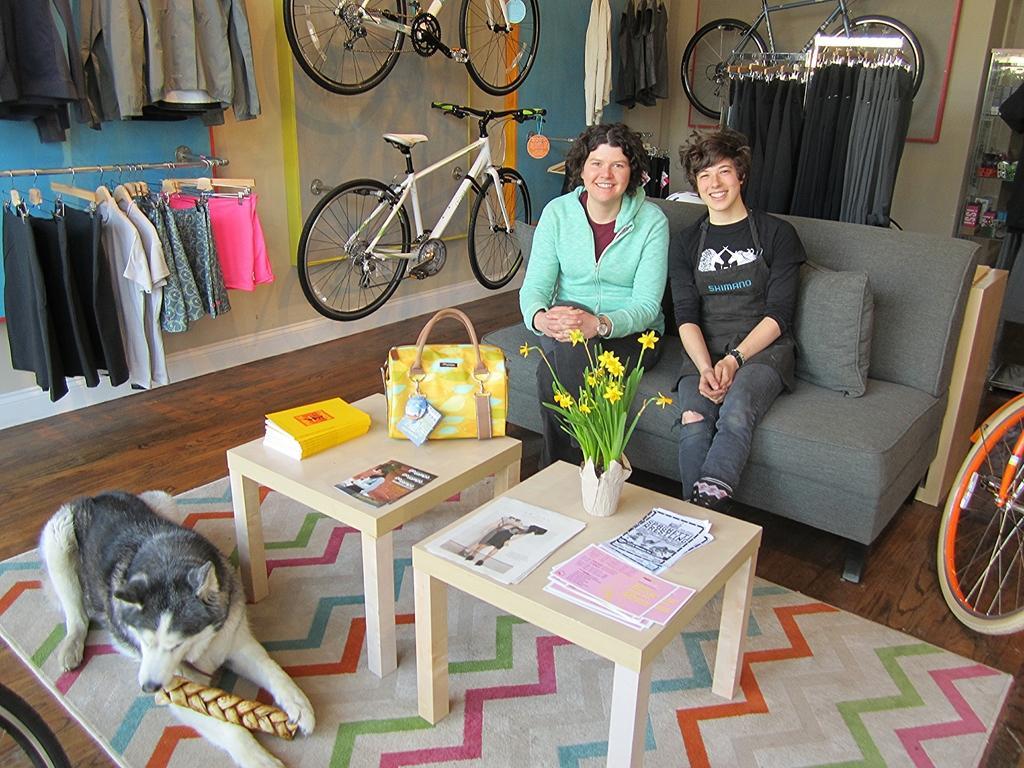Could you give a brief overview of what you see in this image? In the middle there is a sofa on that , two people are sitting ,in front of them there are two tables on that there is a book ,hand bag ,flower vase and paper. On the left there is a dog. In the background there are some clothes ,cycles and wall. 